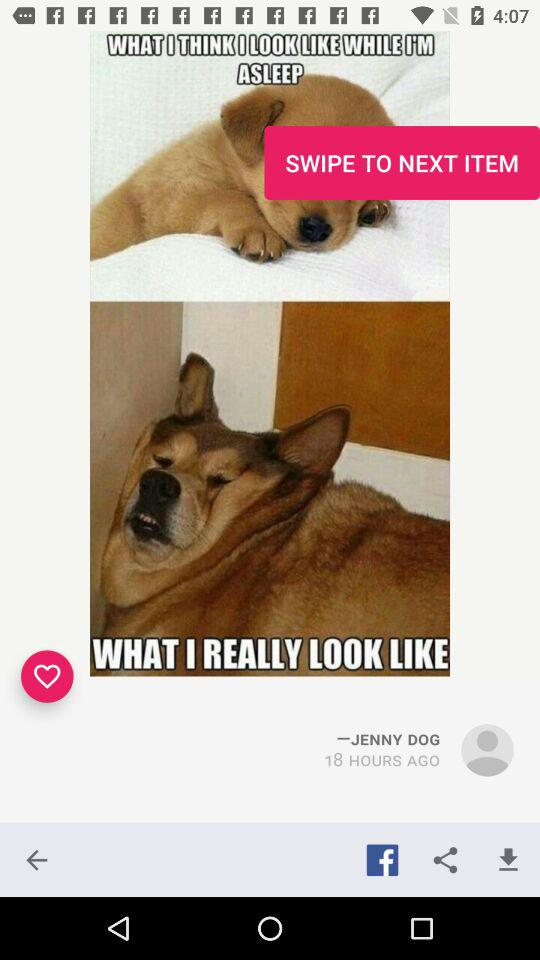What application is used to share? The application used to share is "Facebook". 